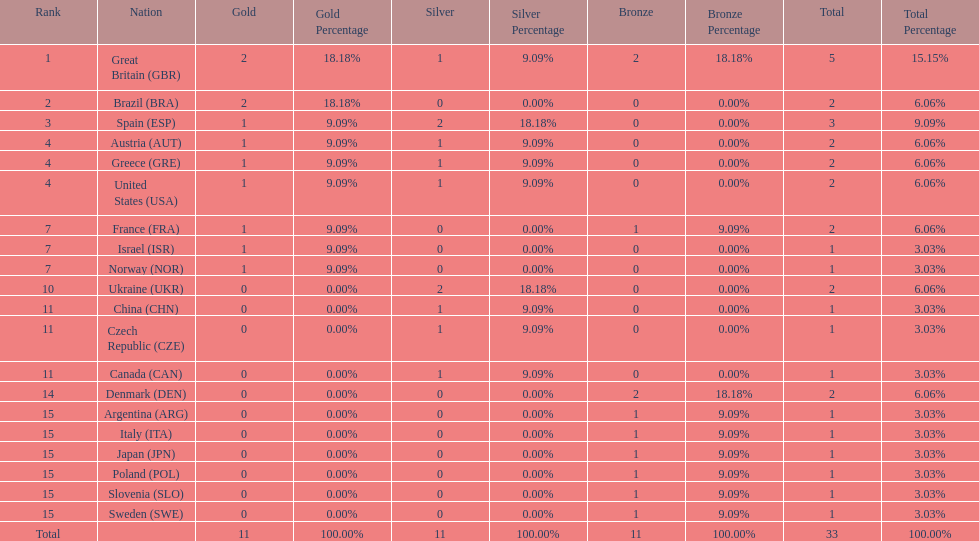How many countries won at least 1 gold and 1 silver medal? 5. 